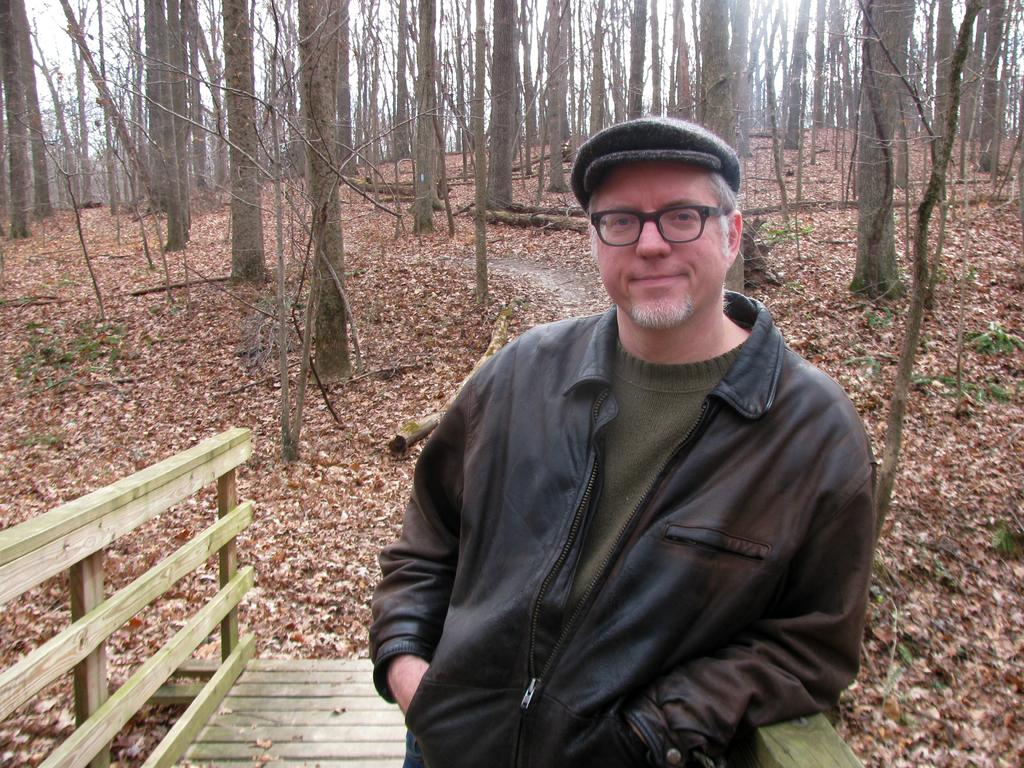What type of natural environment is depicted in the image? The image contains a forest. What can be found on the ground in the forest? There are dry leaves on the ground. Is there a person present in the image? Yes, a man is standing in the image. How many trees are visible in the image? There are many trees in the image. What color is the chalk used by the man in the image? There is no chalk present in the image, and the man is not using any chalk. 